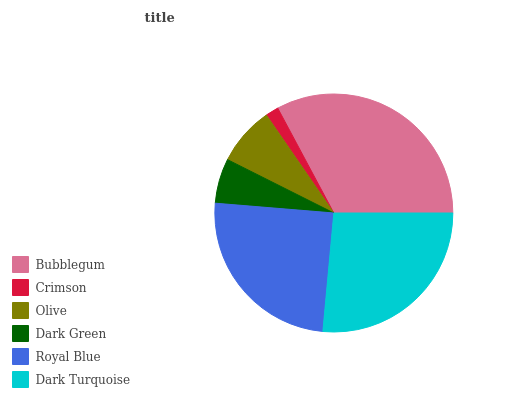Is Crimson the minimum?
Answer yes or no. Yes. Is Bubblegum the maximum?
Answer yes or no. Yes. Is Olive the minimum?
Answer yes or no. No. Is Olive the maximum?
Answer yes or no. No. Is Olive greater than Crimson?
Answer yes or no. Yes. Is Crimson less than Olive?
Answer yes or no. Yes. Is Crimson greater than Olive?
Answer yes or no. No. Is Olive less than Crimson?
Answer yes or no. No. Is Royal Blue the high median?
Answer yes or no. Yes. Is Olive the low median?
Answer yes or no. Yes. Is Dark Turquoise the high median?
Answer yes or no. No. Is Dark Turquoise the low median?
Answer yes or no. No. 